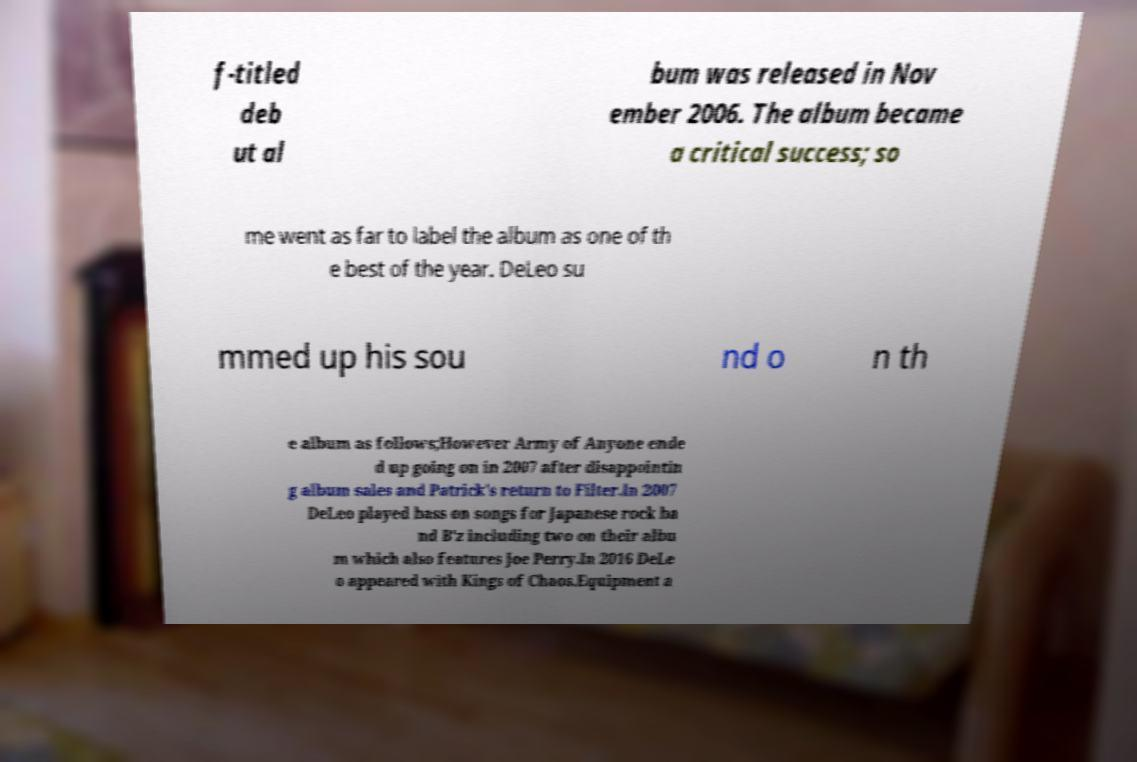Can you accurately transcribe the text from the provided image for me? f-titled deb ut al bum was released in Nov ember 2006. The album became a critical success; so me went as far to label the album as one of th e best of the year. DeLeo su mmed up his sou nd o n th e album as follows;However Army of Anyone ende d up going on in 2007 after disappointin g album sales and Patrick's return to Filter.In 2007 DeLeo played bass on songs for Japanese rock ba nd B'z including two on their albu m which also features Joe Perry.In 2016 DeLe o appeared with Kings of Chaos.Equipment a 